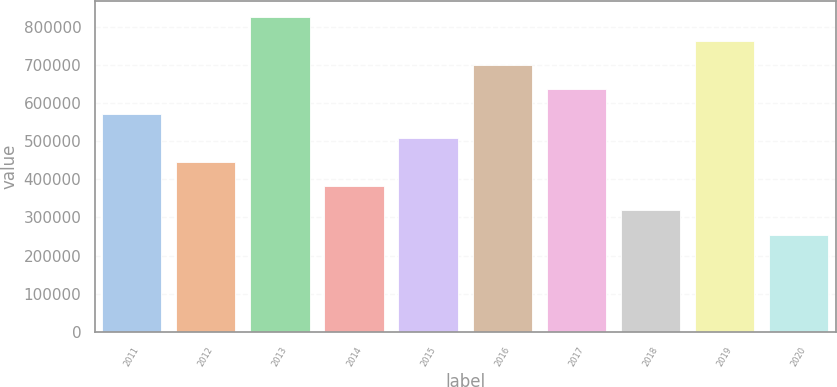<chart> <loc_0><loc_0><loc_500><loc_500><bar_chart><fcel>2011<fcel>2012<fcel>2013<fcel>2014<fcel>2015<fcel>2016<fcel>2017<fcel>2018<fcel>2019<fcel>2020<nl><fcel>572006<fcel>445096<fcel>825825<fcel>381642<fcel>508551<fcel>698916<fcel>635461<fcel>318187<fcel>762370<fcel>254732<nl></chart> 